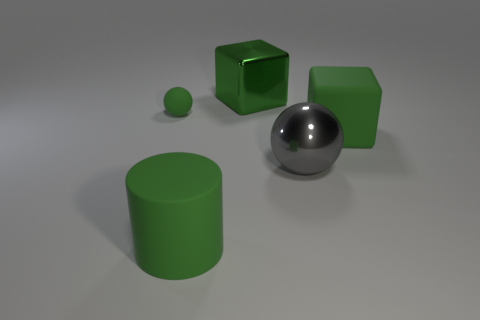Are there the same number of tiny things behind the green shiny object and big rubber cubes that are behind the green rubber cube? While the provided answer was 'yes', a more descriptive response would take into account the actual elements present in the image and their spatial relationships. Upon examining the image, we can see that there is one small sphere behind the green shiny object (which is itself a sphere), and one large rubber cube behind the smaller green rubber cube. Thus, the number of items behind each is not the same, but differs in size and count. 